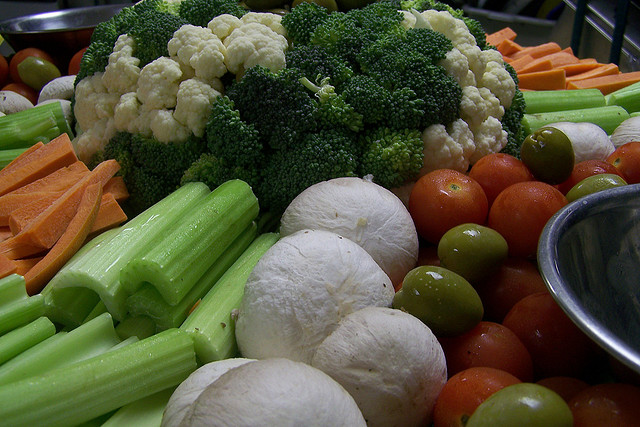<image>What vegetables are in the basket? I am not sure about the vegetables in the basket. However, it might contains carrots, celery, tomatoes, broccoli and cauliflower. What vegetables are in the basket? I am not sure the vegetables are in the basket. But it can be seen carrots, celery, tomatoes, broccoli. 